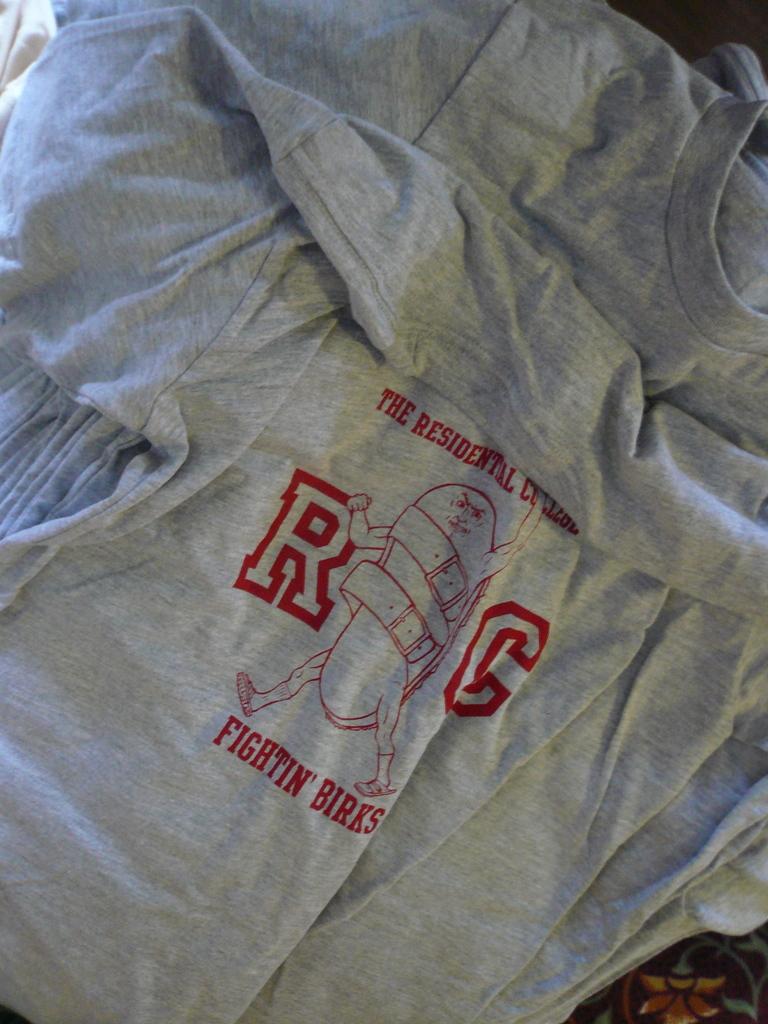What college is listed on this shirt?
Make the answer very short. Rc. What is the name attributed to this college blow the logo?
Provide a short and direct response. Fightin' birks. 